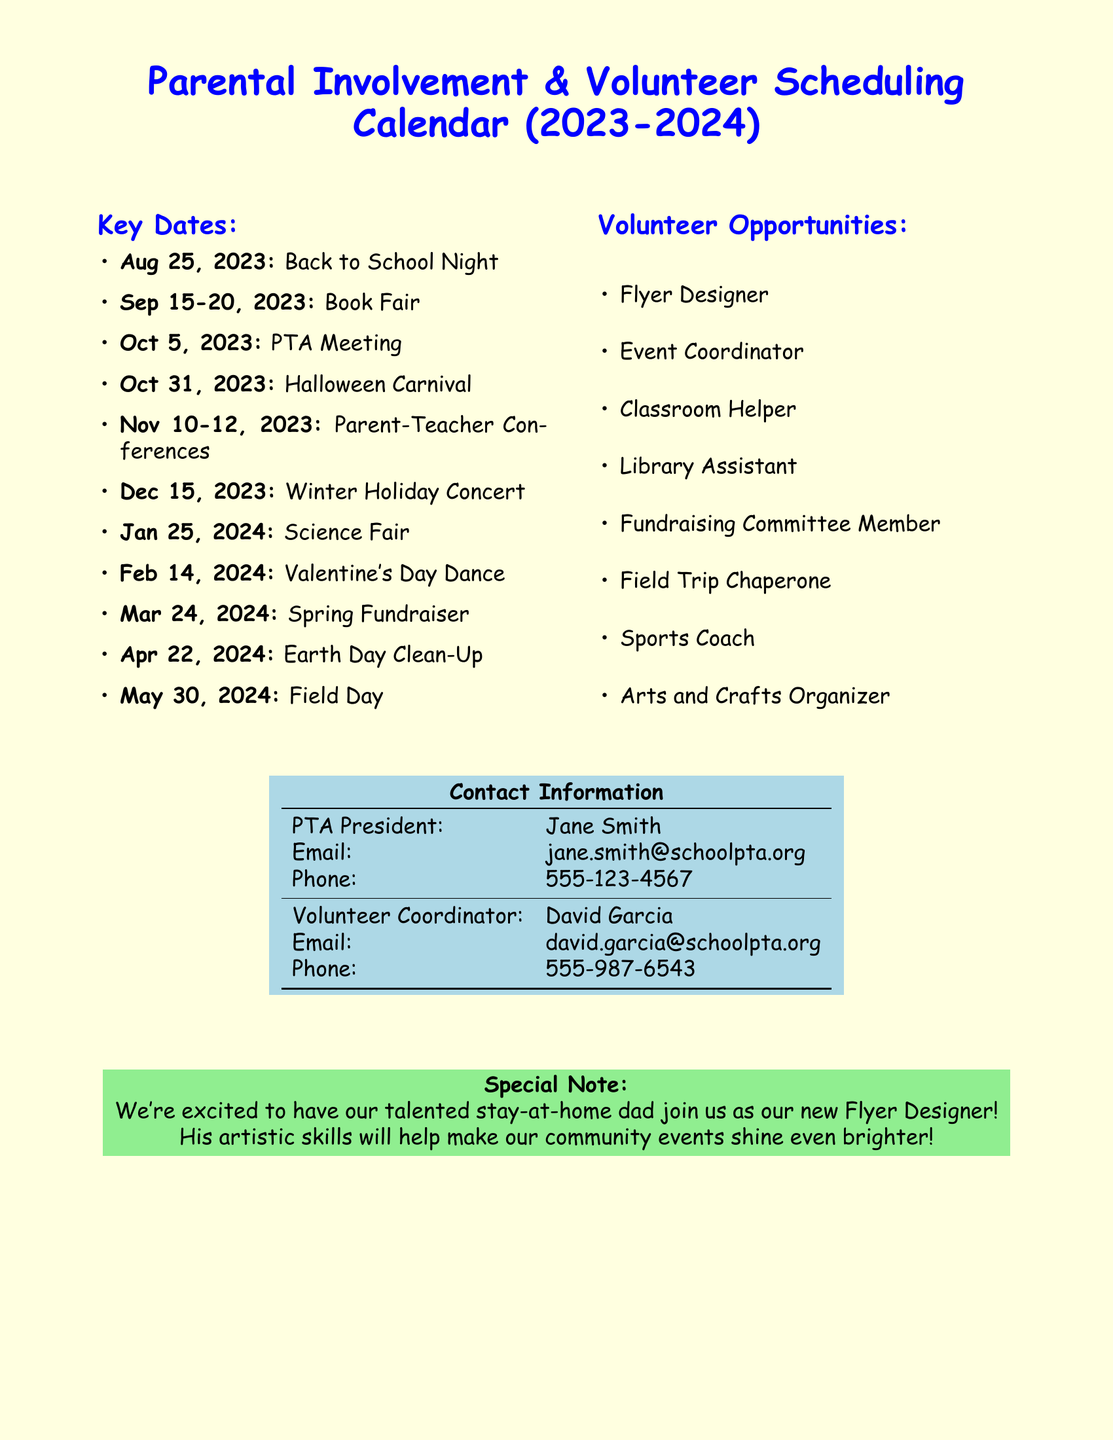what is the date of the Back to School Night? The date of the Back to School Night is listed as August 25, 2023.
Answer: August 25, 2023 what event occurs on October 31, 2023? The document mentions a Halloween Carnival is scheduled for October 31, 2023.
Answer: Halloween Carnival who is the PTA President? The name of the PTA President is provided as Jane Smith in the contact information.
Answer: Jane Smith how many volunteer opportunities are listed? The document includes a total of eight volunteer opportunities listed under Volunteer Opportunities.
Answer: eight which date is the Spring Fundraiser? The Spring Fundraiser is scheduled for March 24, 2024, as indicated in the Key Dates section.
Answer: March 24, 2024 what role is the stay-at-home dad taking? The stay-at-home dad is assigned the role of Flyer Designer, as highlighted in the Special Note section.
Answer: Flyer Designer what is the email of the Volunteer Coordinator? The email address of the Volunteer Coordinator, David Garcia, is given as david.garcia@schoolpta.org.
Answer: david.garcia@schoolpta.org when are the Parent-Teacher Conferences scheduled? The Parent-Teacher Conferences are scheduled for November 10-12, 2023, according to the Key Dates section.
Answer: November 10-12, 2023 what color is used for the page background? The background color of the page is light yellow, as specified in the document layout.
Answer: light yellow 